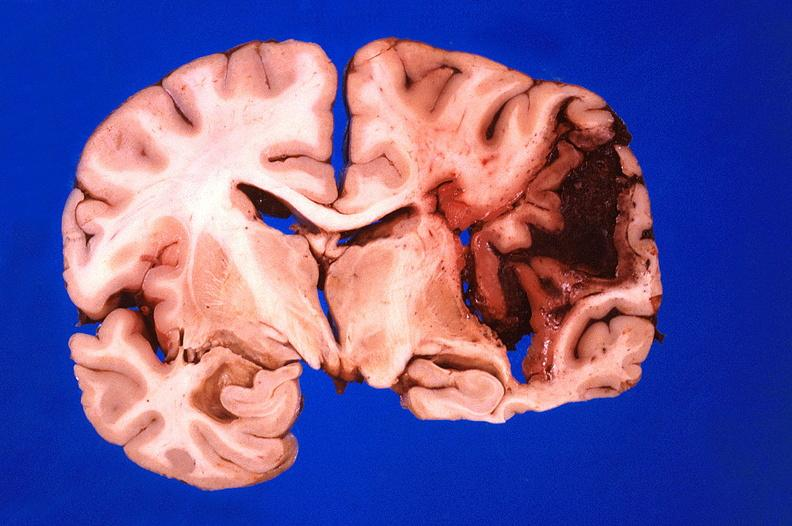why does this image show brain, hematoma?
Answer the question using a single word or phrase. Due to ruptured aneurysm 